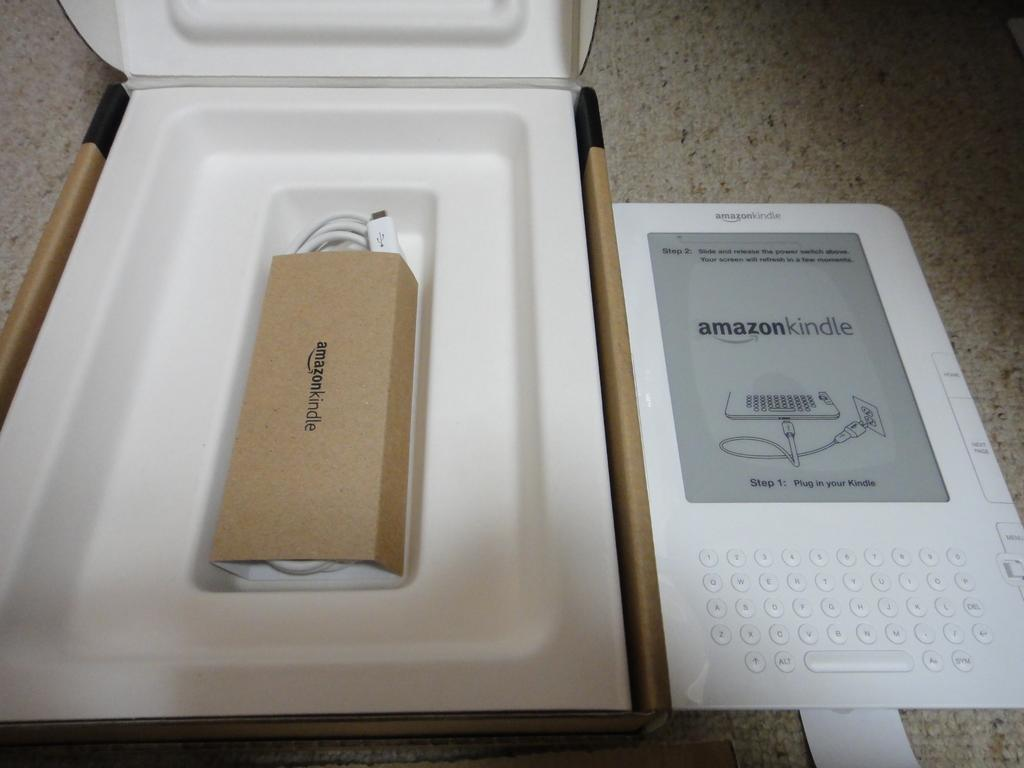Provide a one-sentence caption for the provided image. A white Amazon Kindle sitting next to open packaging. 